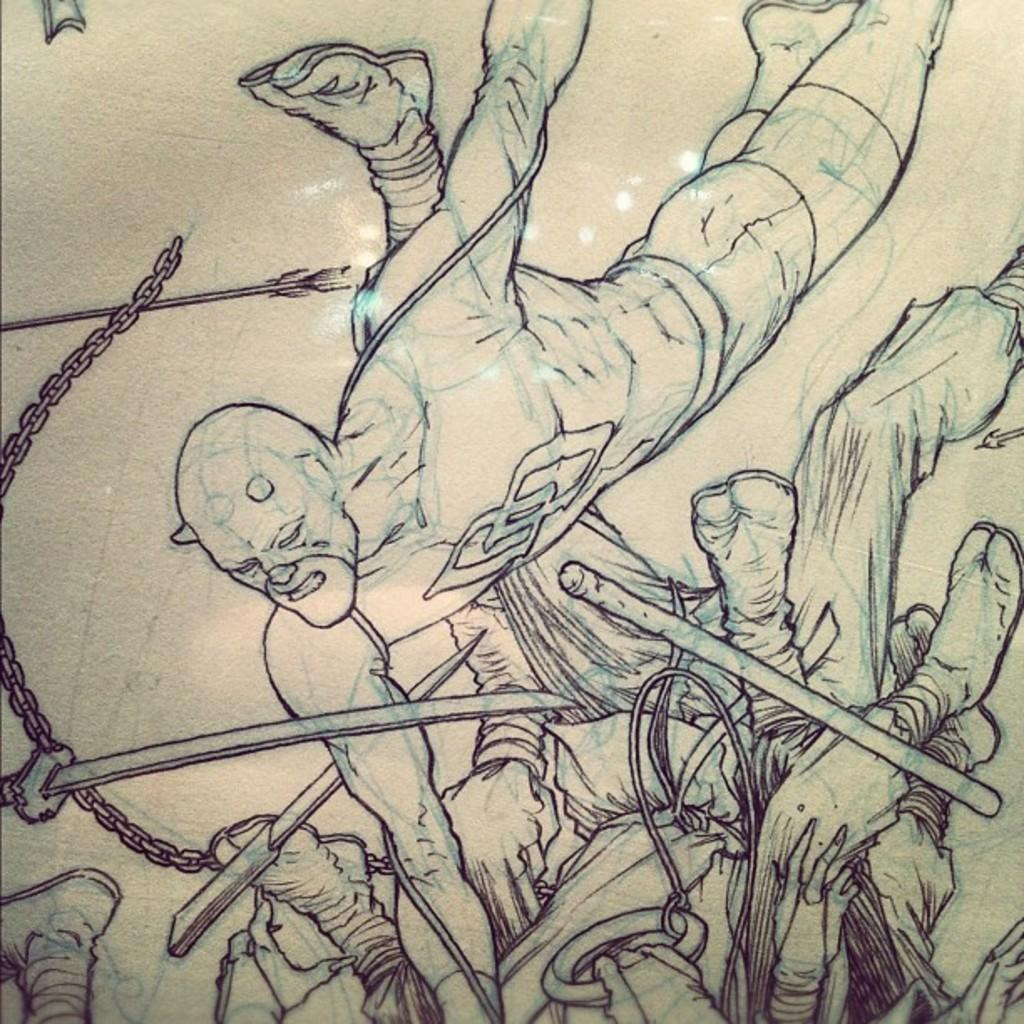What objects are in the foreground of the image? In the foreground of the image, there are knives, a chain, an arrow, people, and a stick. Can you describe the objects in more detail? The knives are sharp and pointy, the chain is made of metal links, the arrow is long and has a sharp tip, the people are standing or walking, and the stick is long and thin. How many objects are in the foreground of the image? There are five objects in the foreground of the image. How many donkeys are visible in the image? There are no donkeys present in the image. What type of chickens can be seen in the image? There are no chickens present in the image. 